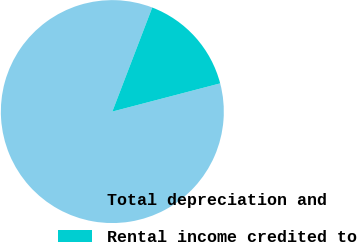Convert chart. <chart><loc_0><loc_0><loc_500><loc_500><pie_chart><fcel>Total depreciation and<fcel>Rental income credited to<nl><fcel>84.9%<fcel>15.1%<nl></chart> 